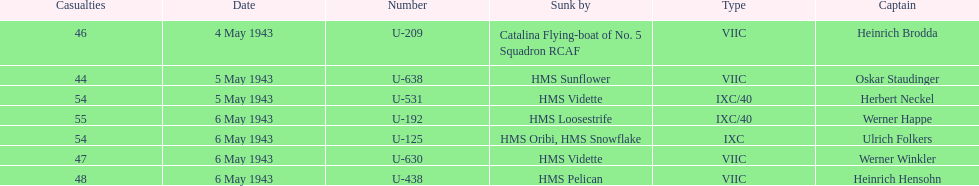Which u-boat was the first to sink U-209. 